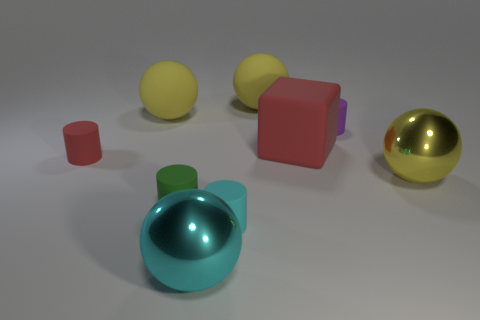Is the number of big rubber cubes that are left of the tiny green matte cylinder less than the number of large cyan spheres right of the tiny cyan rubber cylinder?
Your answer should be very brief. No. There is a ball that is both to the left of the cyan cylinder and in front of the matte cube; what material is it?
Your response must be concise. Metal. The metal thing in front of the shiny sphere that is right of the purple rubber cylinder is what shape?
Your answer should be very brief. Sphere. What number of cyan things are cylinders or large objects?
Your response must be concise. 2. Are there any large yellow metal things in front of the cyan rubber thing?
Offer a very short reply. No. How big is the red cube?
Make the answer very short. Large. What size is the red object that is the same shape as the purple matte object?
Your answer should be compact. Small. What number of large yellow objects are behind the big yellow rubber ball that is on the right side of the small green rubber object?
Ensure brevity in your answer.  0. Does the yellow sphere that is in front of the tiny purple rubber cylinder have the same material as the big yellow object that is to the left of the cyan cylinder?
Keep it short and to the point. No. How many small purple things are the same shape as the tiny cyan rubber object?
Make the answer very short. 1. 